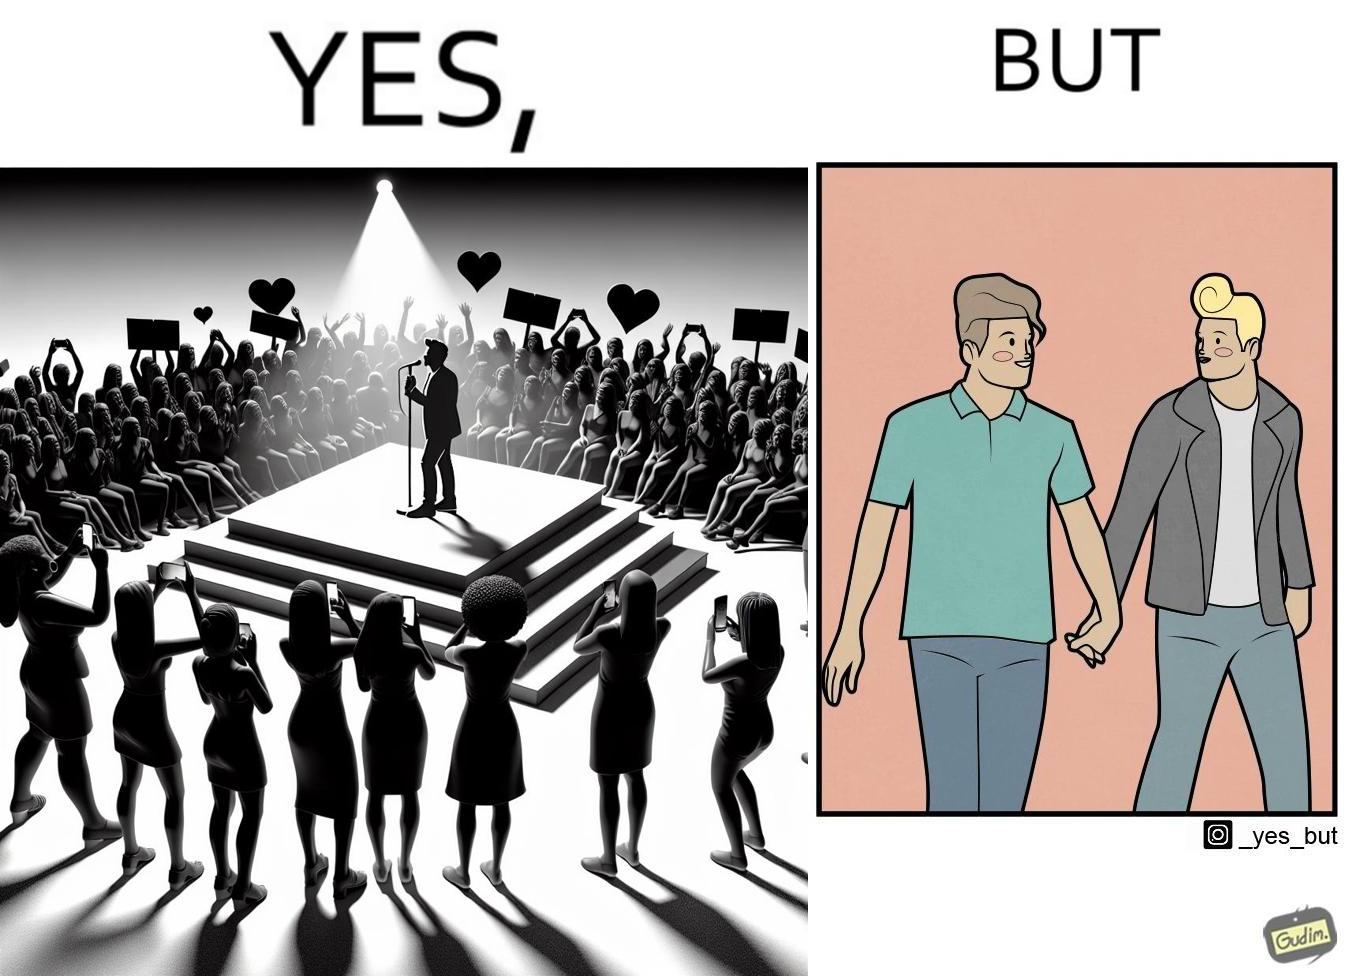Explain the humor or irony in this image. The image is funny because while the girls loves the man, he likes other men instead of women. 